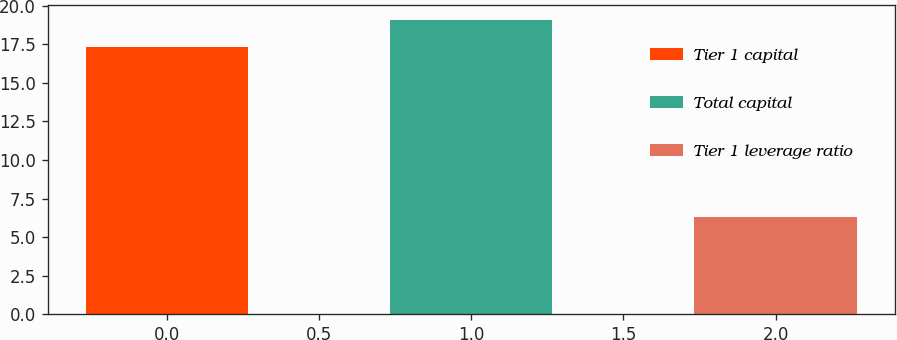<chart> <loc_0><loc_0><loc_500><loc_500><bar_chart><fcel>Tier 1 capital<fcel>Total capital<fcel>Tier 1 leverage ratio<nl><fcel>17.3<fcel>19.1<fcel>6.3<nl></chart> 